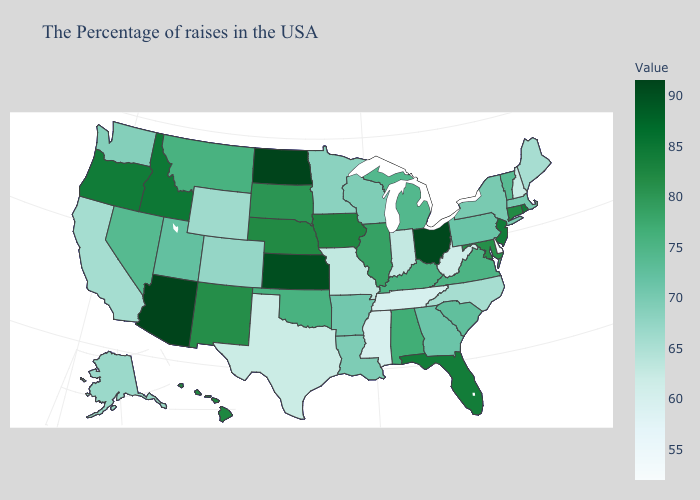Which states hav the highest value in the South?
Keep it brief. Florida. Among the states that border Arizona , does Nevada have the lowest value?
Keep it brief. No. Among the states that border Massachusetts , does New Hampshire have the lowest value?
Write a very short answer. Yes. Among the states that border Louisiana , which have the highest value?
Keep it brief. Arkansas. 